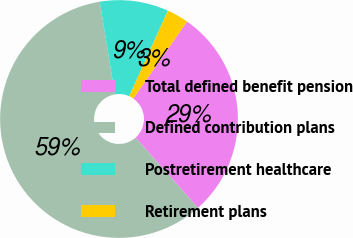<chart> <loc_0><loc_0><loc_500><loc_500><pie_chart><fcel>Total defined benefit pension<fcel>Defined contribution plans<fcel>Postretirement healthcare<fcel>Retirement plans<nl><fcel>28.75%<fcel>58.97%<fcel>9.34%<fcel>2.95%<nl></chart> 